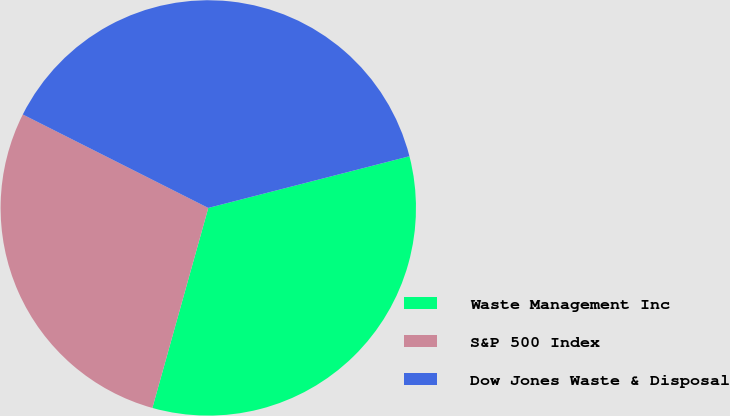<chart> <loc_0><loc_0><loc_500><loc_500><pie_chart><fcel>Waste Management Inc<fcel>S&P 500 Index<fcel>Dow Jones Waste & Disposal<nl><fcel>33.34%<fcel>28.09%<fcel>38.57%<nl></chart> 